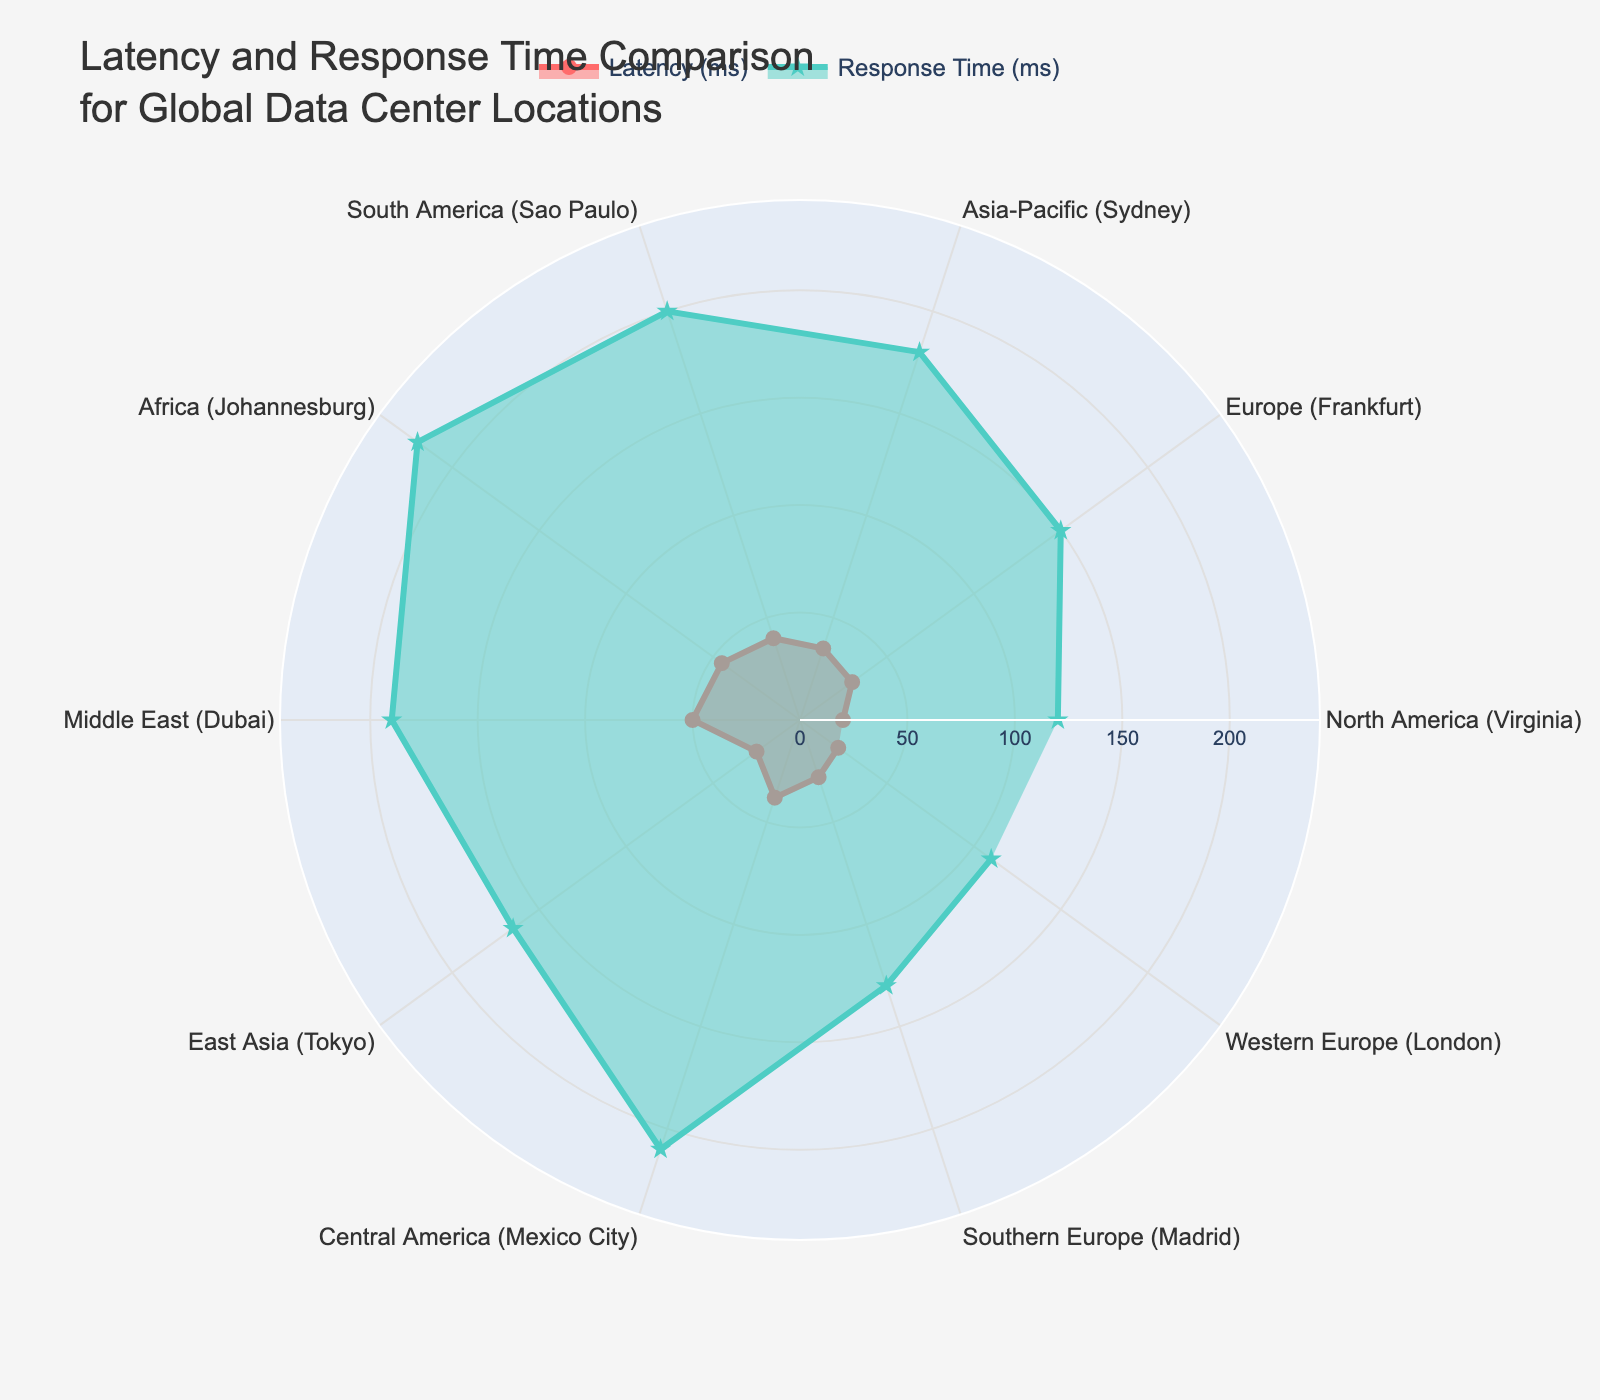What's the maximum latency value and its corresponding location? To find the maximum latency value, look at the radar chart and identify the highest point on the 'Latency (ms)' trace. The highest point is 50 ms, which corresponds to the Middle East (Dubai).
Answer: 50 ms, Middle East (Dubai) Which location has the lowest response time? To determine the location with the lowest response time, observe the 'Response Time (ms)' trace and find the lowest point. The lowest response time is at Western Europe (London) with 110 ms.
Answer: Western Europe (London) Compare the latency between North America (Virginia) and East Asia (Tokyo); which is higher? By comparing the two points on the 'Latency (ms)' trace for North America (Virginia) and East Asia (Tokyo), North America (Virginia) has a latency of 20 ms, and East Asia (Tokyo) has a latency of 25 ms. Therefore, East Asia (Tokyo) has a higher latency.
Answer: East Asia (Tokyo) Calculate the average response time for the locations in Europe (Frankfurt, Madrid, and London). First, identify the response times for the locations in Europe: Frankfurt (150 ms), Madrid (130 ms), and London (110 ms). Sum these values: 150 + 130 + 110 = 390 ms. Then divide by the number of locations: 390 ms / 3 = 130 ms.
Answer: 130 ms Which location stands out as having both higher latency and response time relative to its region? From the radar chart, South America (Sao Paulo) stands out with both high latency (40 ms) and high response time (200 ms) relative to other regions.
Answer: South America (Sao Paulo) Determine the median latency value across all locations. List the latencies in order: 20, 22, 25, 28, 30, 35, 38, 40, 45, 50. The median is the middle value of this ordered list. Since there are 10 values, take the average of the 5th and 6th values: (30 + 35) / 2 = 32.5 ms.
Answer: 32.5 ms Which location has the most significant difference between latency and response time, and what is that difference? To find the most significant difference, subtract the latency from the response time for each location: North America (100 ms), Europe (120 ms), Asia-Pacific (145 ms), South America (160 ms), Africa (175 ms), Middle East (140 ms), East Asia (140 ms), Central America (172 ms), Southern Europe (102 ms), Western Europe (88 ms). The maximum difference is Africa (Johannesburg) with 175 ms.
Answer: Africa (Johannesburg), 175 ms Identify the region with the smallest variation between latency and response time. To identify the smallest variation, look at the differences: North America (100 ms), Europe (120 ms), Asia-Pacific (145 ms), South America (160 ms), Africa (175 ms), Middle East (140 ms), East Asia (140 ms), Central America (172 ms), Southern Europe (102 ms), Western Europe (88 ms). The smallest difference is Western Europe (London) with 88 ms.
Answer: Western Europe (London), 88 ms Rank the locations by their response times from lowest to highest. Order the response times and their corresponding locations: London (110 ms), Virginia (120 ms), Madrid (130 ms), Frankfurt (150 ms), Tokyo (165 ms), Dubai (190 ms), Sydney (180 ms), Sao Paulo (200 ms), Mexico City (210 ms), Johannesburg (220 ms).
Answer: London, Virginia, Madrid, Frankfurt, Tokyo, Sydney, Dubai, Sao Paulo, Mexico City, Johannesburg 